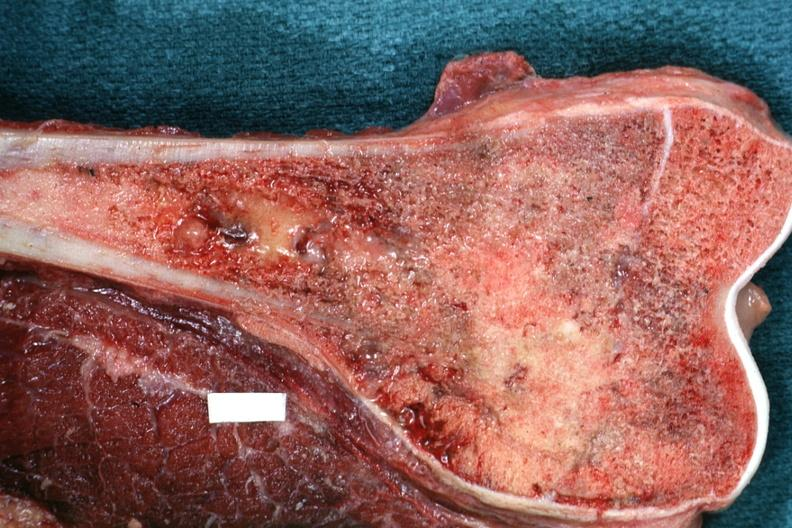does this image show sectioned femur lesion is distal end excellent example?
Answer the question using a single word or phrase. Yes 